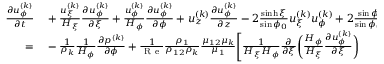Convert formula to latex. <formula><loc_0><loc_0><loc_500><loc_500>\begin{array} { r } { \begin{array} { r l } { \frac { \partial u _ { \phi } ^ { ( k ) } } { \partial t } } & + \frac { u _ { \xi } ^ { ( k ) } } { H _ { \xi } } \frac { \partial u _ { \phi } ^ { ( k ) } } { \partial \xi } + \frac { u _ { \phi } ^ { ( k ) } } { H _ { \phi } } \frac { \partial u _ { \phi } ^ { ( k ) } } { \partial \phi } + u _ { z } ^ { ( k ) } \frac { \partial u _ { \phi } ^ { ( k ) } } { \partial z } - 2 \frac { \sinh \xi } { \sin \phi _ { 0 } } u _ { \xi } ^ { ( k ) } u _ { \phi } ^ { ( k ) } + 2 \frac { \sin \phi } { \sin \phi _ { 0 } } \left ( u _ { \xi } ^ { ( k ) } \right ) ^ { 2 } } \\ { = } & - \frac { 1 } { \rho _ { k } } \frac { 1 } { H _ { \phi } } \frac { \partial p ^ { ( k ) } } { \partial \phi } + \frac { 1 } { R e } \frac { \rho _ { 1 } } { \rho _ { 1 2 } \rho _ { k } } \frac { \mu _ { 1 2 } \mu _ { k } } { \mu _ { 1 } } \Big [ \frac { 1 } { H _ { \xi } H _ { \phi } } \frac { \partial } { \partial \xi } \Big ( \frac { H _ { \phi } } { H _ { \xi } } \frac { \partial u _ { \phi } ^ { ( k ) } } { \partial \xi } \Big ) } \end{array} } \end{array}</formula> 